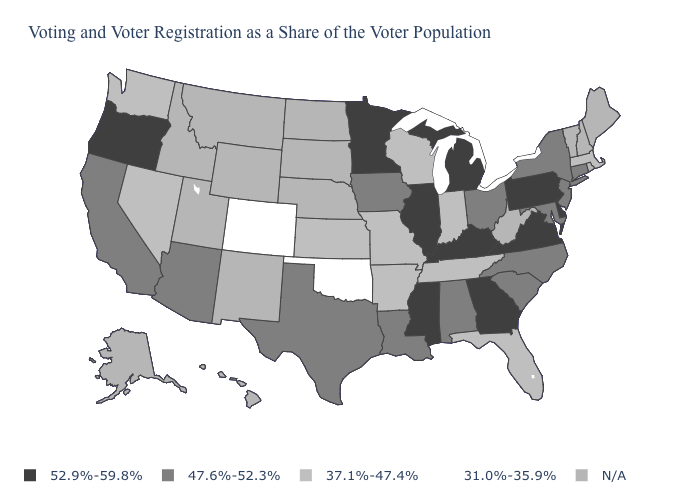Among the states that border Kentucky , which have the lowest value?
Be succinct. Indiana, Missouri, Tennessee. Among the states that border Connecticut , which have the lowest value?
Give a very brief answer. Massachusetts. What is the value of Alabama?
Keep it brief. 47.6%-52.3%. What is the value of Tennessee?
Short answer required. 37.1%-47.4%. What is the value of Maryland?
Write a very short answer. 47.6%-52.3%. What is the value of South Dakota?
Give a very brief answer. N/A. What is the value of Connecticut?
Be succinct. 47.6%-52.3%. Among the states that border Nevada , which have the highest value?
Be succinct. Oregon. Name the states that have a value in the range 52.9%-59.8%?
Write a very short answer. Delaware, Georgia, Illinois, Kentucky, Michigan, Minnesota, Mississippi, Oregon, Pennsylvania, Virginia. Name the states that have a value in the range 31.0%-35.9%?
Keep it brief. Colorado, Oklahoma. What is the value of Alaska?
Answer briefly. N/A. Among the states that border Delaware , which have the highest value?
Quick response, please. Pennsylvania. What is the value of Montana?
Give a very brief answer. N/A. 